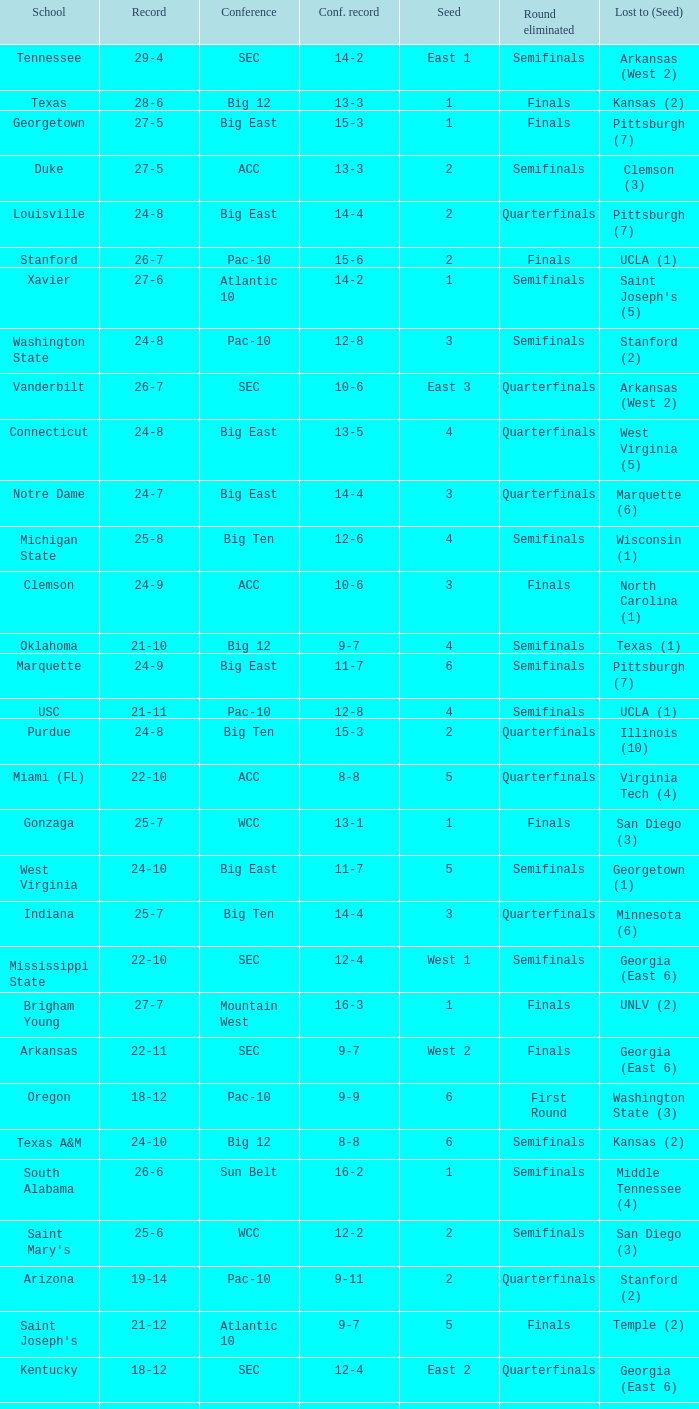I'm looking to parse the entire table for insights. Could you assist me with that? {'header': ['School', 'Record', 'Conference', 'Conf. record', 'Seed', 'Round eliminated', 'Lost to (Seed)'], 'rows': [['Tennessee', '29-4', 'SEC', '14-2', 'East 1', 'Semifinals', 'Arkansas (West 2)'], ['Texas', '28-6', 'Big 12', '13-3', '1', 'Finals', 'Kansas (2)'], ['Georgetown', '27-5', 'Big East', '15-3', '1', 'Finals', 'Pittsburgh (7)'], ['Duke', '27-5', 'ACC', '13-3', '2', 'Semifinals', 'Clemson (3)'], ['Louisville', '24-8', 'Big East', '14-4', '2', 'Quarterfinals', 'Pittsburgh (7)'], ['Stanford', '26-7', 'Pac-10', '15-6', '2', 'Finals', 'UCLA (1)'], ['Xavier', '27-6', 'Atlantic 10', '14-2', '1', 'Semifinals', "Saint Joseph's (5)"], ['Washington State', '24-8', 'Pac-10', '12-8', '3', 'Semifinals', 'Stanford (2)'], ['Vanderbilt', '26-7', 'SEC', '10-6', 'East 3', 'Quarterfinals', 'Arkansas (West 2)'], ['Connecticut', '24-8', 'Big East', '13-5', '4', 'Quarterfinals', 'West Virginia (5)'], ['Notre Dame', '24-7', 'Big East', '14-4', '3', 'Quarterfinals', 'Marquette (6)'], ['Michigan State', '25-8', 'Big Ten', '12-6', '4', 'Semifinals', 'Wisconsin (1)'], ['Clemson', '24-9', 'ACC', '10-6', '3', 'Finals', 'North Carolina (1)'], ['Oklahoma', '21-10', 'Big 12', '9-7', '4', 'Semifinals', 'Texas (1)'], ['Marquette', '24-9', 'Big East', '11-7', '6', 'Semifinals', 'Pittsburgh (7)'], ['USC', '21-11', 'Pac-10', '12-8', '4', 'Semifinals', 'UCLA (1)'], ['Purdue', '24-8', 'Big Ten', '15-3', '2', 'Quarterfinals', 'Illinois (10)'], ['Miami (FL)', '22-10', 'ACC', '8-8', '5', 'Quarterfinals', 'Virginia Tech (4)'], ['Gonzaga', '25-7', 'WCC', '13-1', '1', 'Finals', 'San Diego (3)'], ['West Virginia', '24-10', 'Big East', '11-7', '5', 'Semifinals', 'Georgetown (1)'], ['Indiana', '25-7', 'Big Ten', '14-4', '3', 'Quarterfinals', 'Minnesota (6)'], ['Mississippi State', '22-10', 'SEC', '12-4', 'West 1', 'Semifinals', 'Georgia (East 6)'], ['Brigham Young', '27-7', 'Mountain West', '16-3', '1', 'Finals', 'UNLV (2)'], ['Arkansas', '22-11', 'SEC', '9-7', 'West 2', 'Finals', 'Georgia (East 6)'], ['Oregon', '18-12', 'Pac-10', '9-9', '6', 'First Round', 'Washington State (3)'], ['Texas A&M', '24-10', 'Big 12', '8-8', '6', 'Semifinals', 'Kansas (2)'], ['South Alabama', '26-6', 'Sun Belt', '16-2', '1', 'Semifinals', 'Middle Tennessee (4)'], ["Saint Mary's", '25-6', 'WCC', '12-2', '2', 'Semifinals', 'San Diego (3)'], ['Arizona', '19-14', 'Pac-10', '9-11', '2', 'Quarterfinals', 'Stanford (2)'], ["Saint Joseph's", '21-12', 'Atlantic 10', '9-7', '5', 'Finals', 'Temple (2)'], ['Kentucky', '18-12', 'SEC', '12-4', 'East 2', 'Quarterfinals', 'Georgia (East 6)'], ['Kansas State', '20-11', 'Big 12', '10-6', '2', 'Final', 'Texas (1)'], ['Baylor', '21-10', 'Big 12', '9-7', '5', 'First Round', 'Colorado (12)']]} Identify the conference record that has a 3 seed and a 24-9 record. 10-6. 